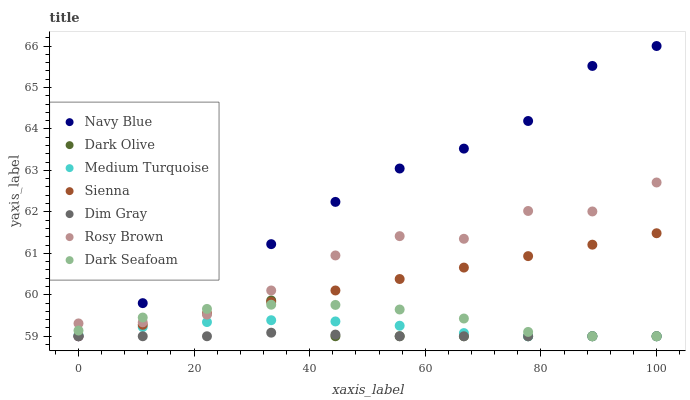Does Dim Gray have the minimum area under the curve?
Answer yes or no. Yes. Does Navy Blue have the maximum area under the curve?
Answer yes or no. Yes. Does Dark Olive have the minimum area under the curve?
Answer yes or no. No. Does Dark Olive have the maximum area under the curve?
Answer yes or no. No. Is Sienna the smoothest?
Answer yes or no. Yes. Is Rosy Brown the roughest?
Answer yes or no. Yes. Is Navy Blue the smoothest?
Answer yes or no. No. Is Navy Blue the roughest?
Answer yes or no. No. Does Dim Gray have the lowest value?
Answer yes or no. Yes. Does Rosy Brown have the lowest value?
Answer yes or no. No. Does Navy Blue have the highest value?
Answer yes or no. Yes. Does Dark Olive have the highest value?
Answer yes or no. No. Is Dim Gray less than Rosy Brown?
Answer yes or no. Yes. Is Rosy Brown greater than Medium Turquoise?
Answer yes or no. Yes. Does Rosy Brown intersect Navy Blue?
Answer yes or no. Yes. Is Rosy Brown less than Navy Blue?
Answer yes or no. No. Is Rosy Brown greater than Navy Blue?
Answer yes or no. No. Does Dim Gray intersect Rosy Brown?
Answer yes or no. No. 